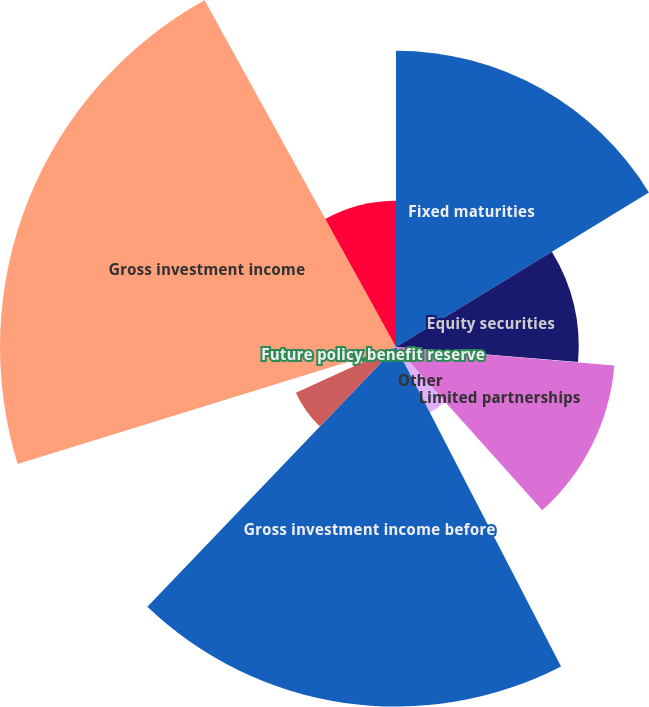<chart> <loc_0><loc_0><loc_500><loc_500><pie_chart><fcel>Fixed maturities<fcel>Equity securities<fcel>Short-term investments and<fcel>Limited partnerships<fcel>Other<fcel>Gross investment income before<fcel>Funds held interest income<fcel>Future policy benefit reserve<fcel>Gross investment income<fcel>Investment expenses<nl><fcel>16.27%<fcel>10.03%<fcel>0.04%<fcel>12.03%<fcel>4.04%<fcel>19.74%<fcel>6.04%<fcel>2.04%<fcel>21.74%<fcel>8.03%<nl></chart> 